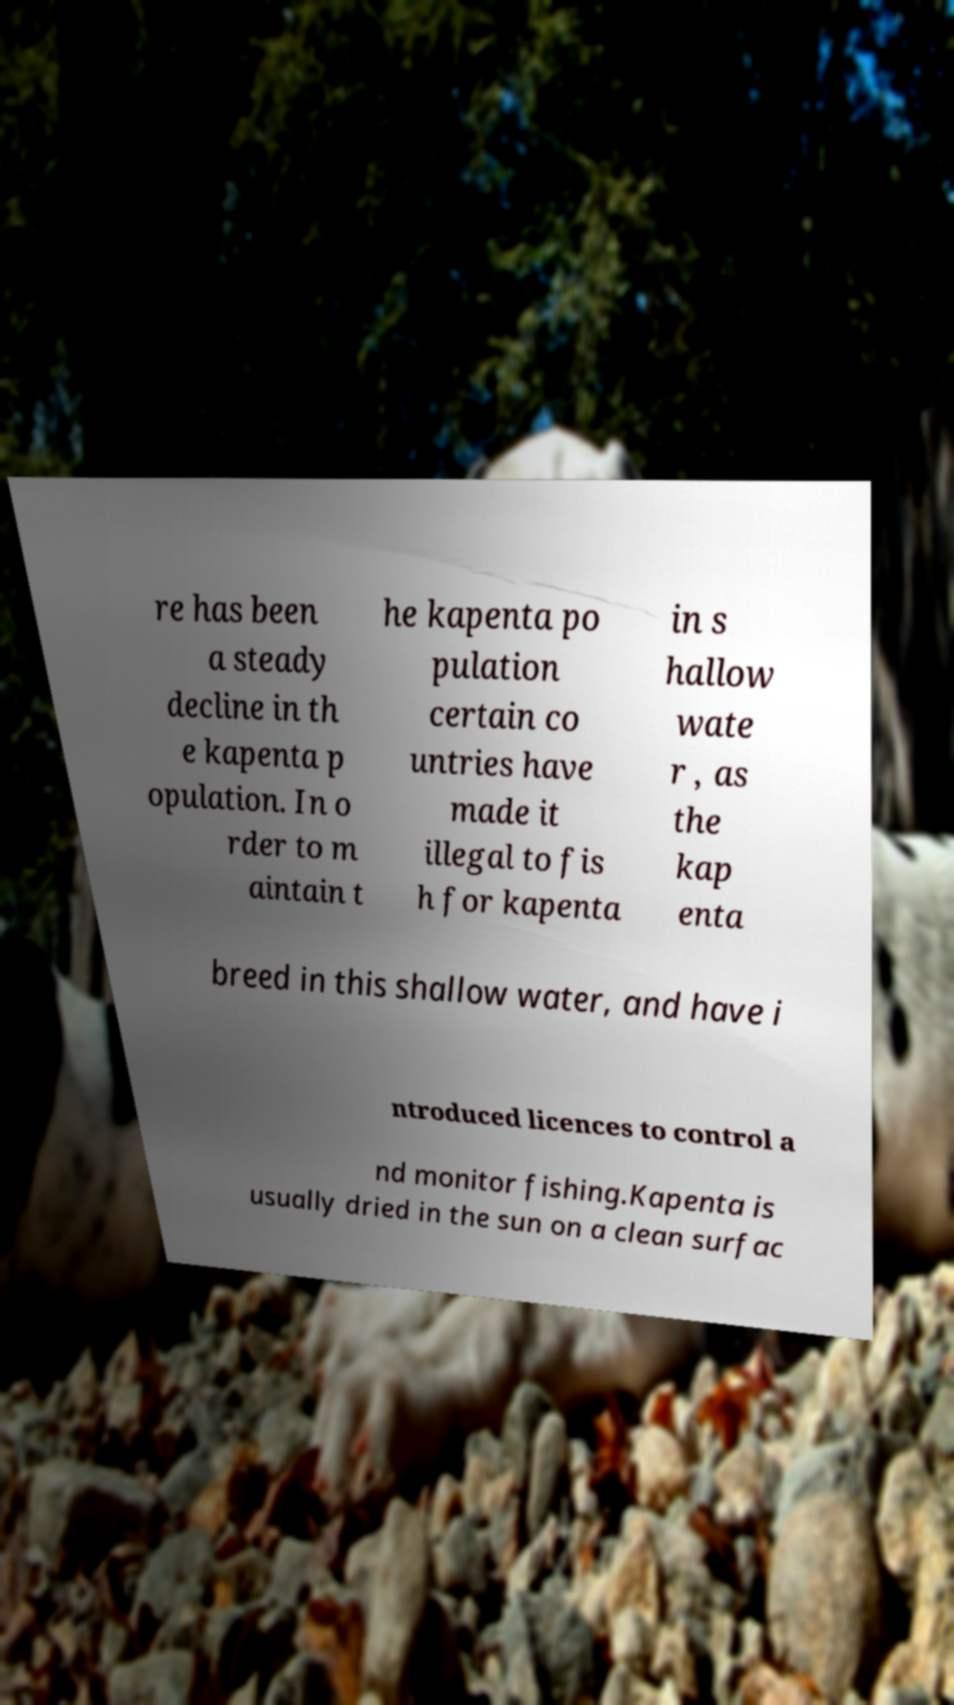Could you assist in decoding the text presented in this image and type it out clearly? re has been a steady decline in th e kapenta p opulation. In o rder to m aintain t he kapenta po pulation certain co untries have made it illegal to fis h for kapenta in s hallow wate r , as the kap enta breed in this shallow water, and have i ntroduced licences to control a nd monitor fishing.Kapenta is usually dried in the sun on a clean surfac 